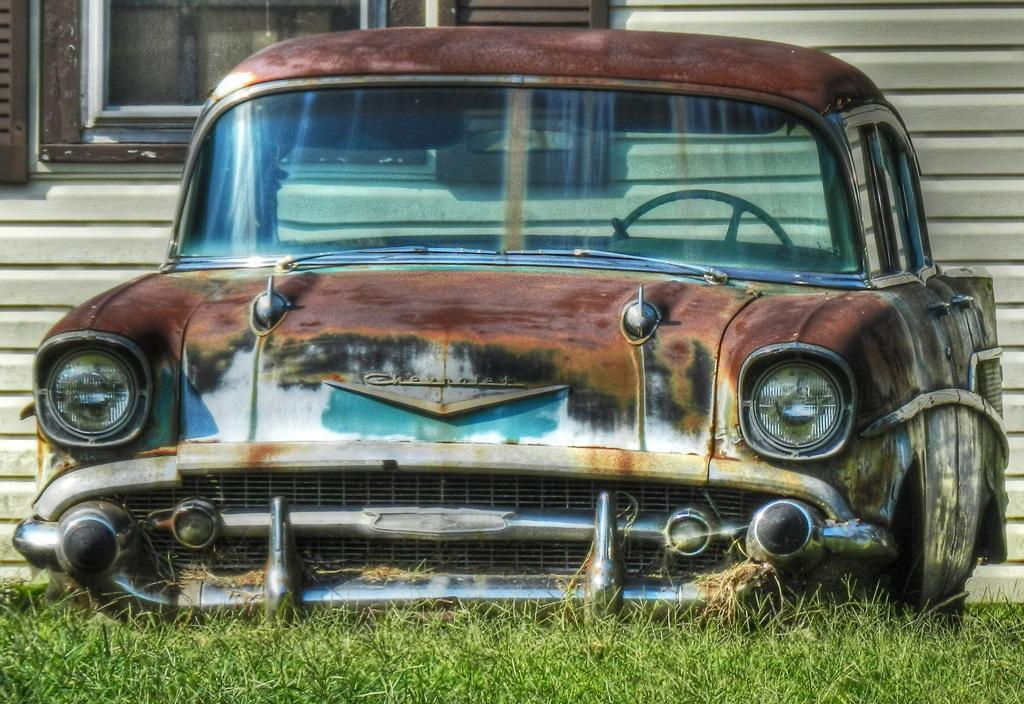In one or two sentences, can you explain what this image depicts? In the center of the image we can see old rusted car. At the bottom there is grass. In the background there is a wall and a window. 